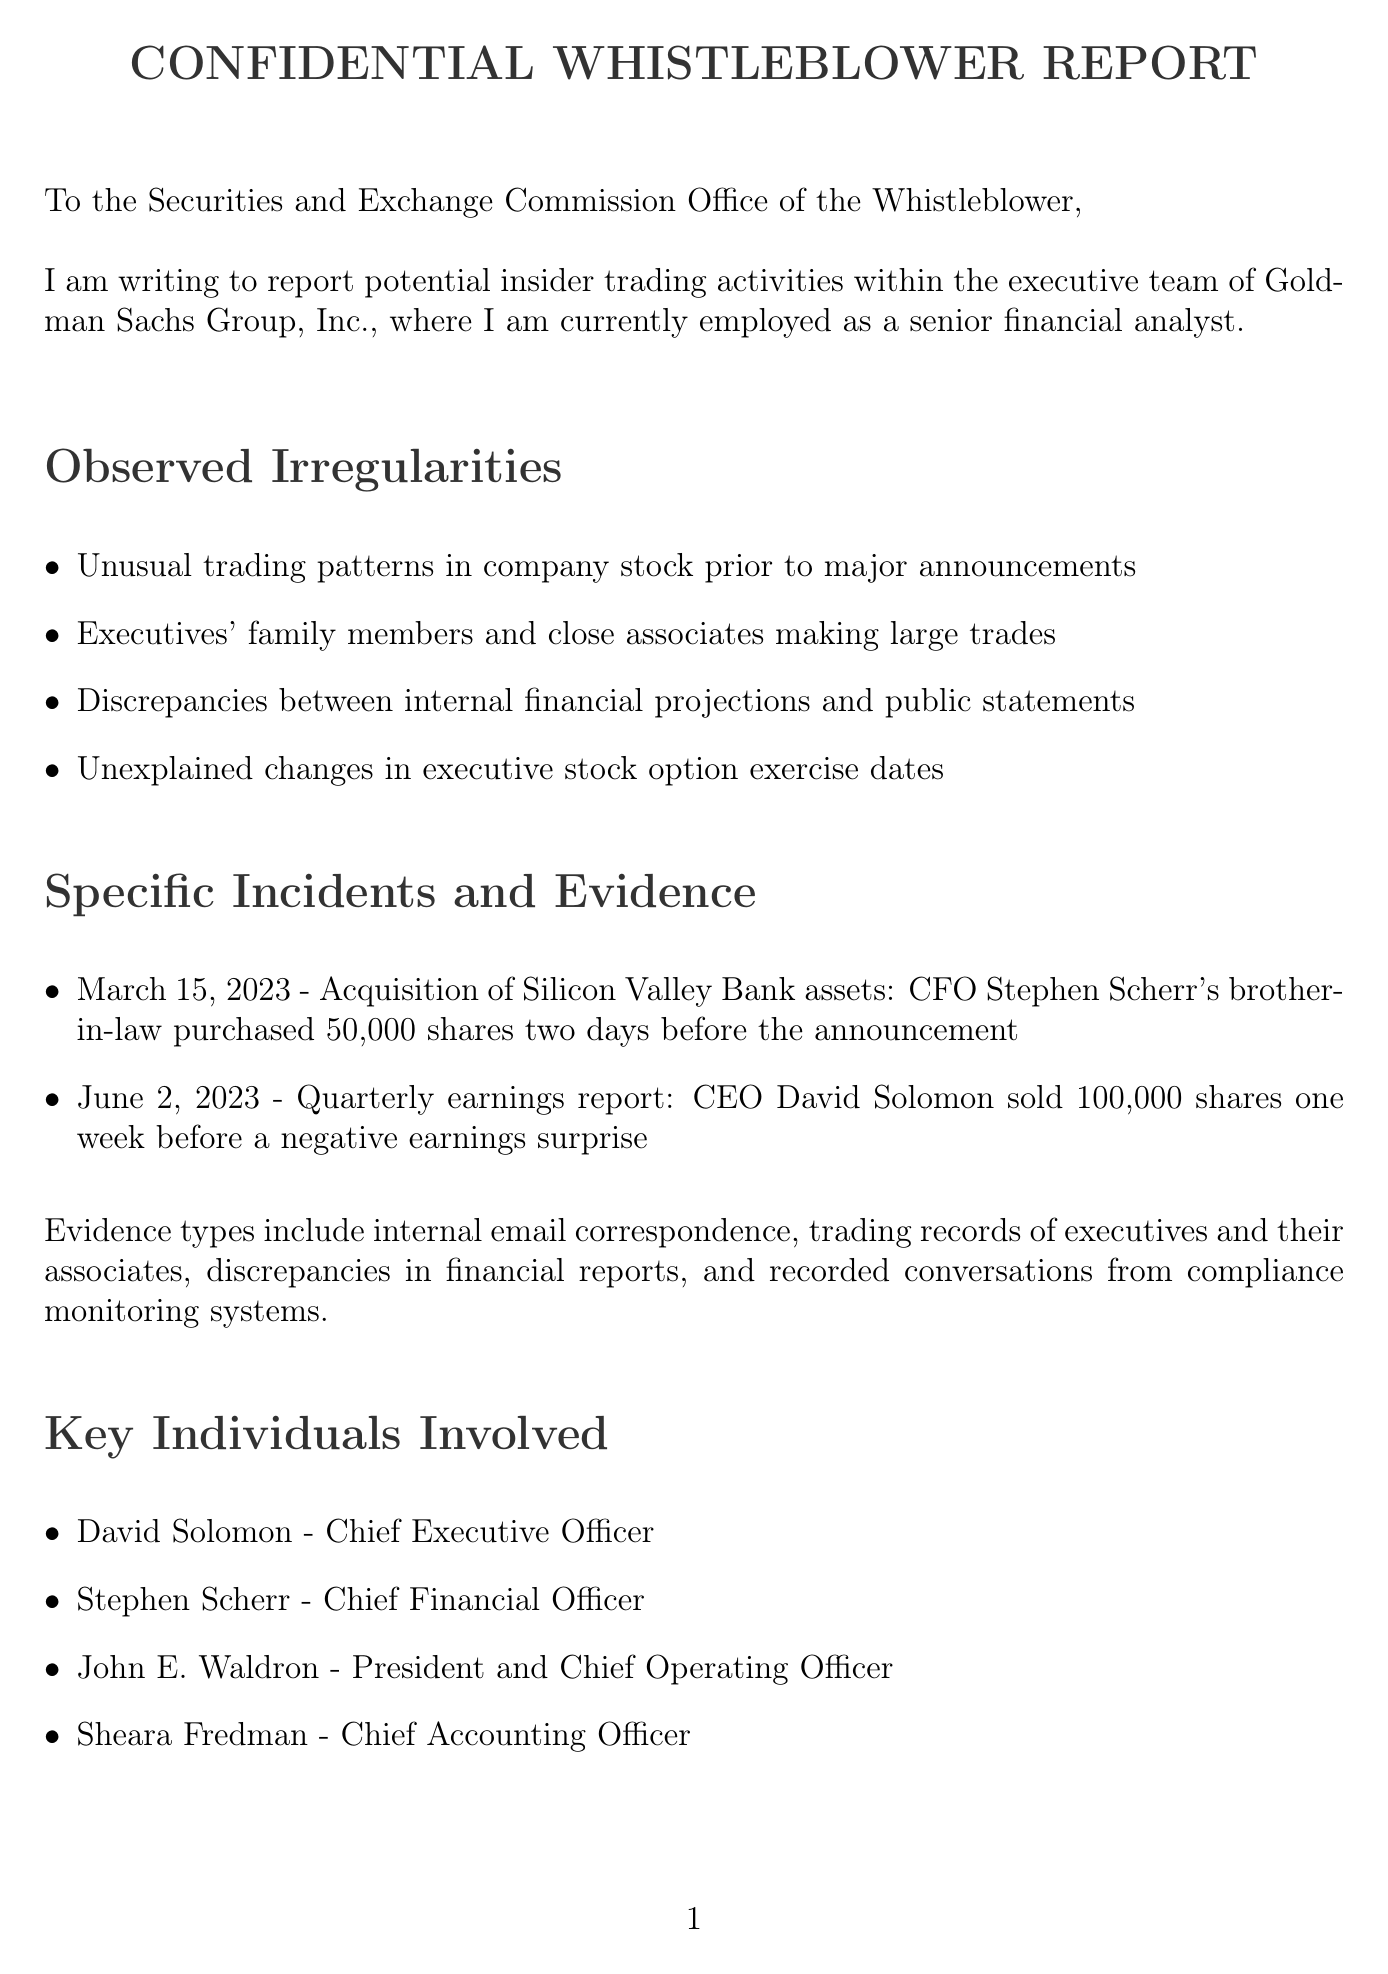What is the recipient of the letter? The recipient is the Securities and Exchange Commission Office of the Whistleblower, as addressed at the beginning of the document.
Answer: Securities and Exchange Commission Office of the Whistleblower Who is reporting the insider trading activities? The author of the letter is a senior financial analyst at Goldman Sachs Group, Inc. reporting the activities.
Answer: senior financial analyst What specific date is mentioned for the acquisition of Silicon Valley Bank assets? The letter specifies March 15, 2023, as the date of the incident regarding the acquisition.
Answer: March 15, 2023 How many shares did CFO Stephen Scherr's brother-in-law purchase? The document states that he purchased 50,000 shares prior to the announcement.
Answer: 50,000 shares What is one potential impact on shareholders mentioned in the letter? The letter lists erosion of investor confidence in Goldman Sachs as a potential impact.
Answer: erosion of investor confidence Who sold 100,000 shares one week before a negative earnings surprise? The document indicates that CEO David Solomon sold this amount of shares before the earnings report.
Answer: David Solomon What type of evidence is mentioned in the letter? Various types of evidence are listed, including internal email correspondence and trading records.
Answer: internal email correspondence What act is cited in relation to insider trading regulations? The letter mentions the Securities Exchange Act of 1934 as part of the regulations being violated.
Answer: Securities Exchange Act of 1934 What does the author request from the Securities and Exchange Commission? The author requests an investigation into the potential insider trading violations.
Answer: investigation 